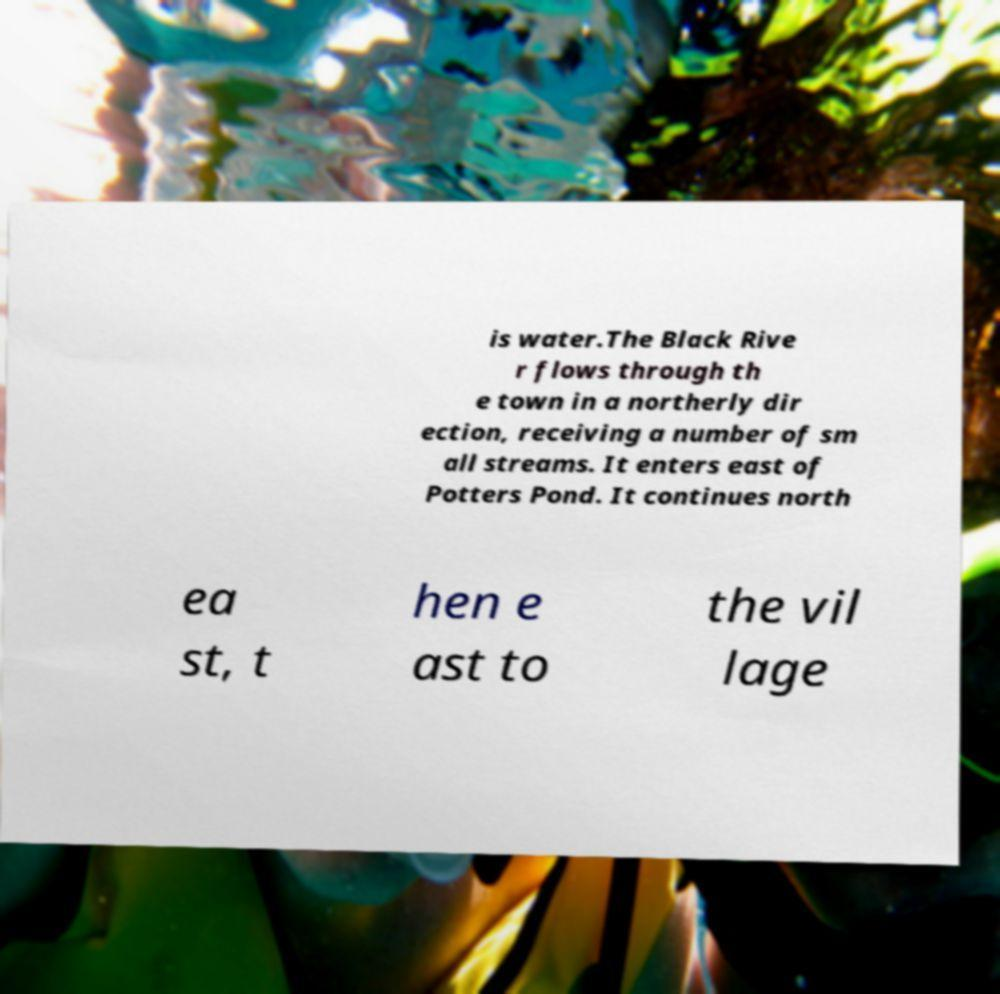Can you read and provide the text displayed in the image?This photo seems to have some interesting text. Can you extract and type it out for me? is water.The Black Rive r flows through th e town in a northerly dir ection, receiving a number of sm all streams. It enters east of Potters Pond. It continues north ea st, t hen e ast to the vil lage 